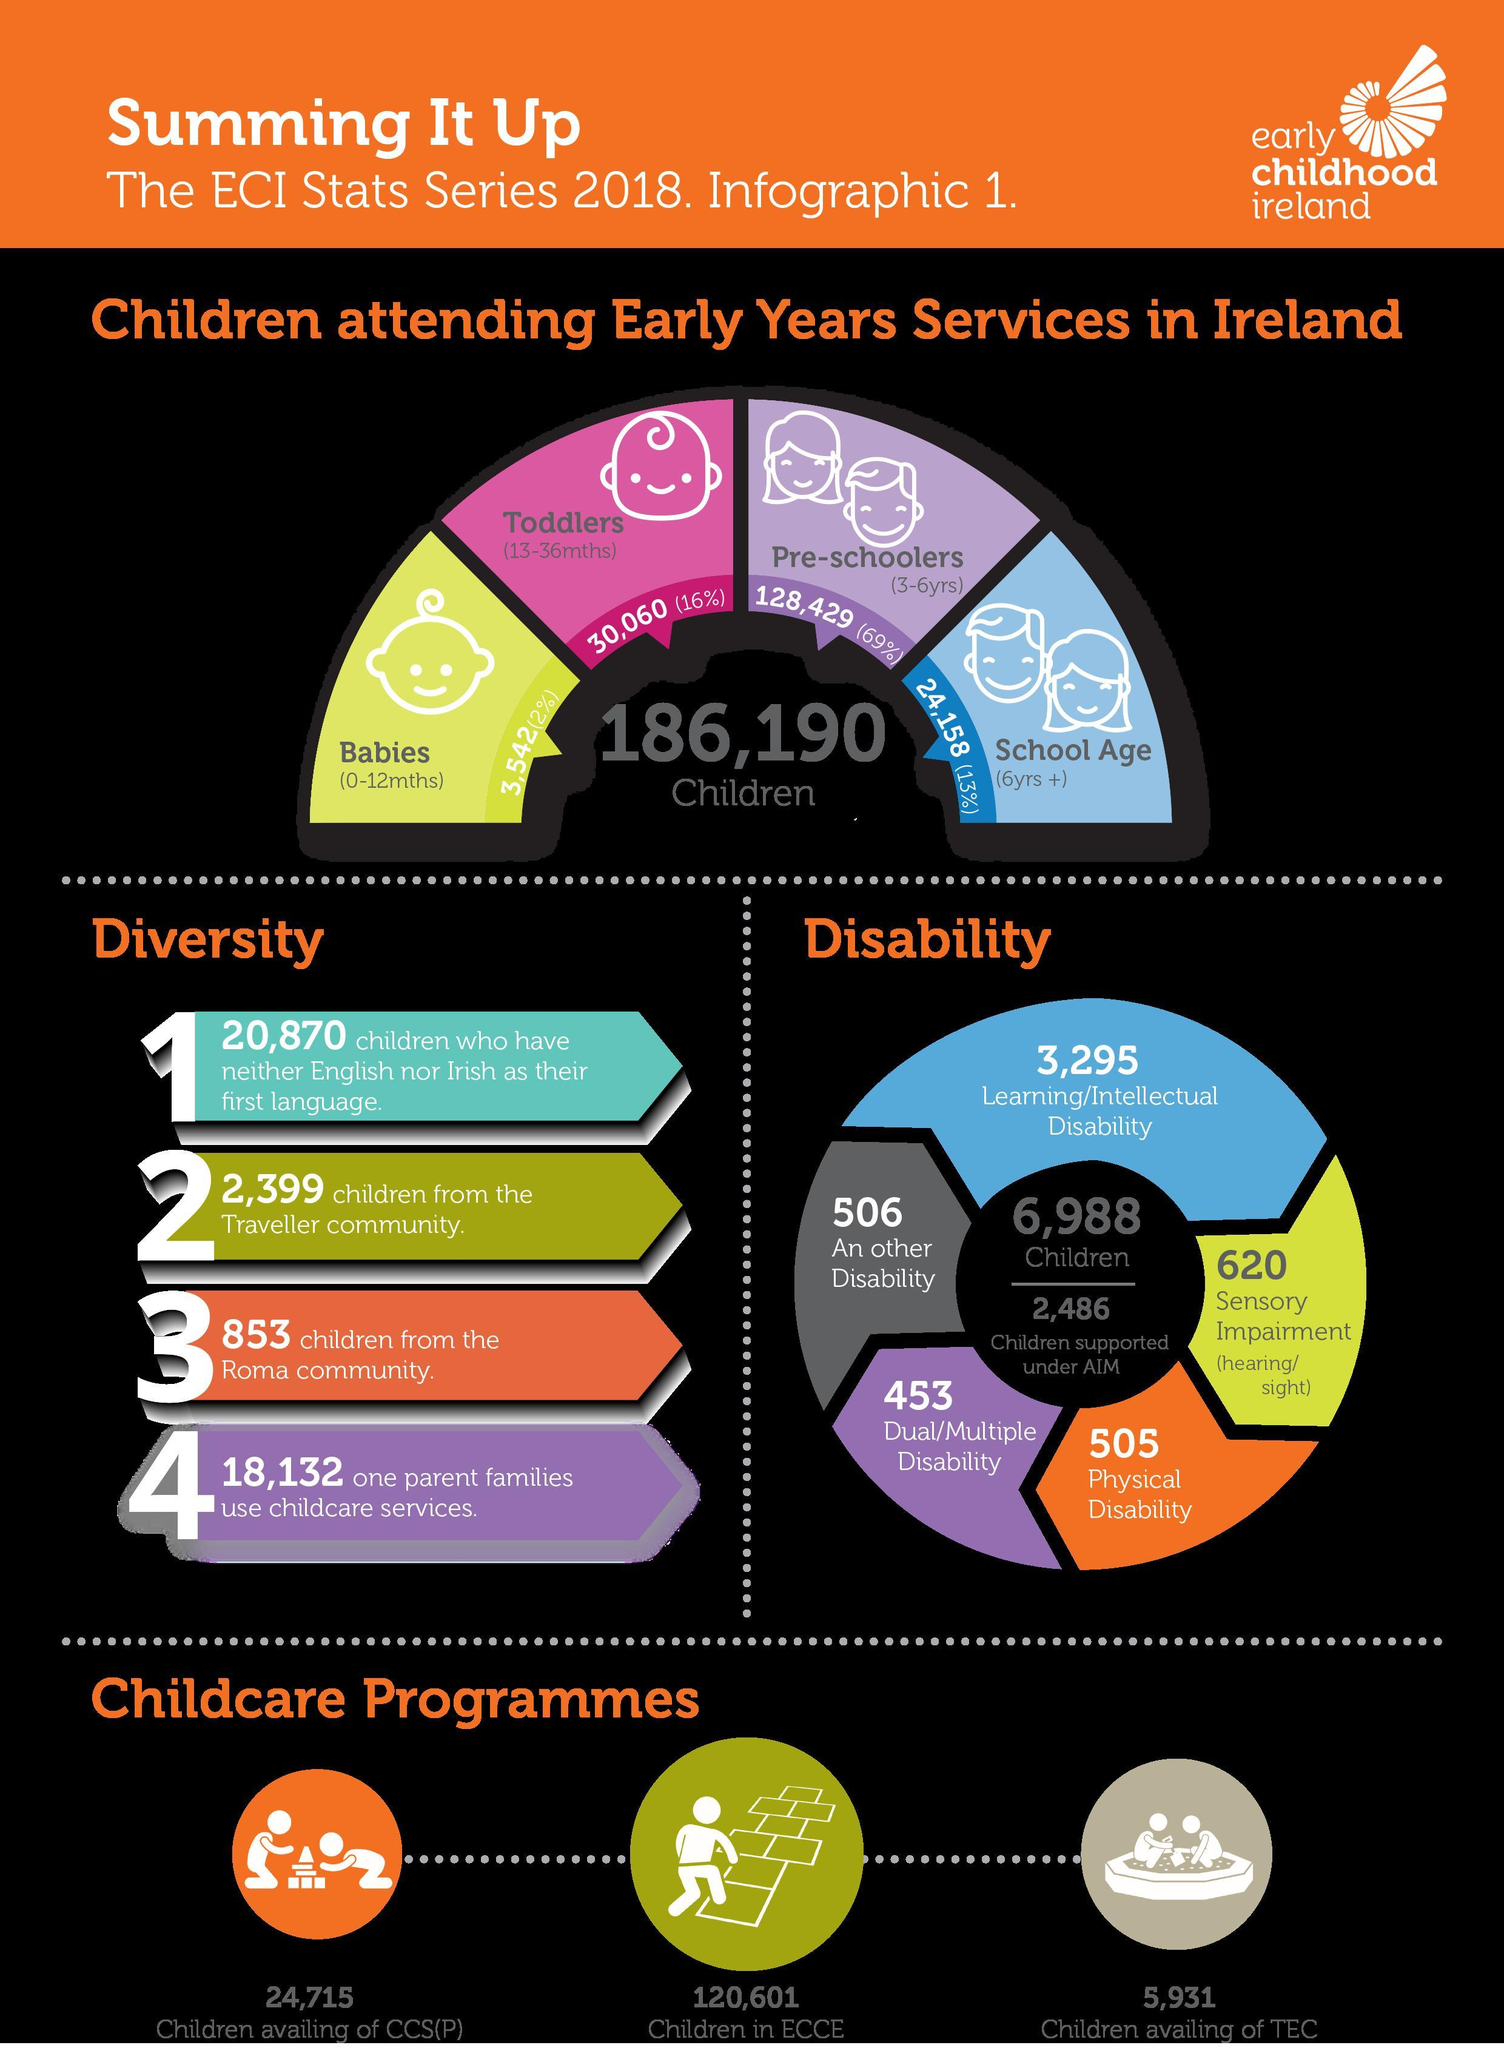What percentage of preschoolers aged 3-6 years were attending early years services in Ireland as per the ECI Stats Series 2018?
Answer the question with a short phrase. 69% What percentage of toddlers (13-36months) were attending early years services in Ireland  as per the ECI Stats Series 2018? 16% How many school children aged 6 years & above were attending early years services in Ireland as per the ECI Stats Series 2018? 24,158 How many children were involved in ECCE programme in Ireland according to the ECI Stats Series 2018? 120,601 How many children in Ireland have physical disability as per the ECI Stats Series 2018? 505 How many children in Ireland have dual or multiple disability as per the ECI Stats Series 2018? 453 How many children were availing of TEC in Ireland according to the ECI Stats Series 2018? 5,931 How many babies aged 0-12 months were attending early years services in Ireland as per the ECI Stats Series 2018? 3,542 How many children in Ireland have sensory impairment as per the ECI Stats Series 2018? 620 